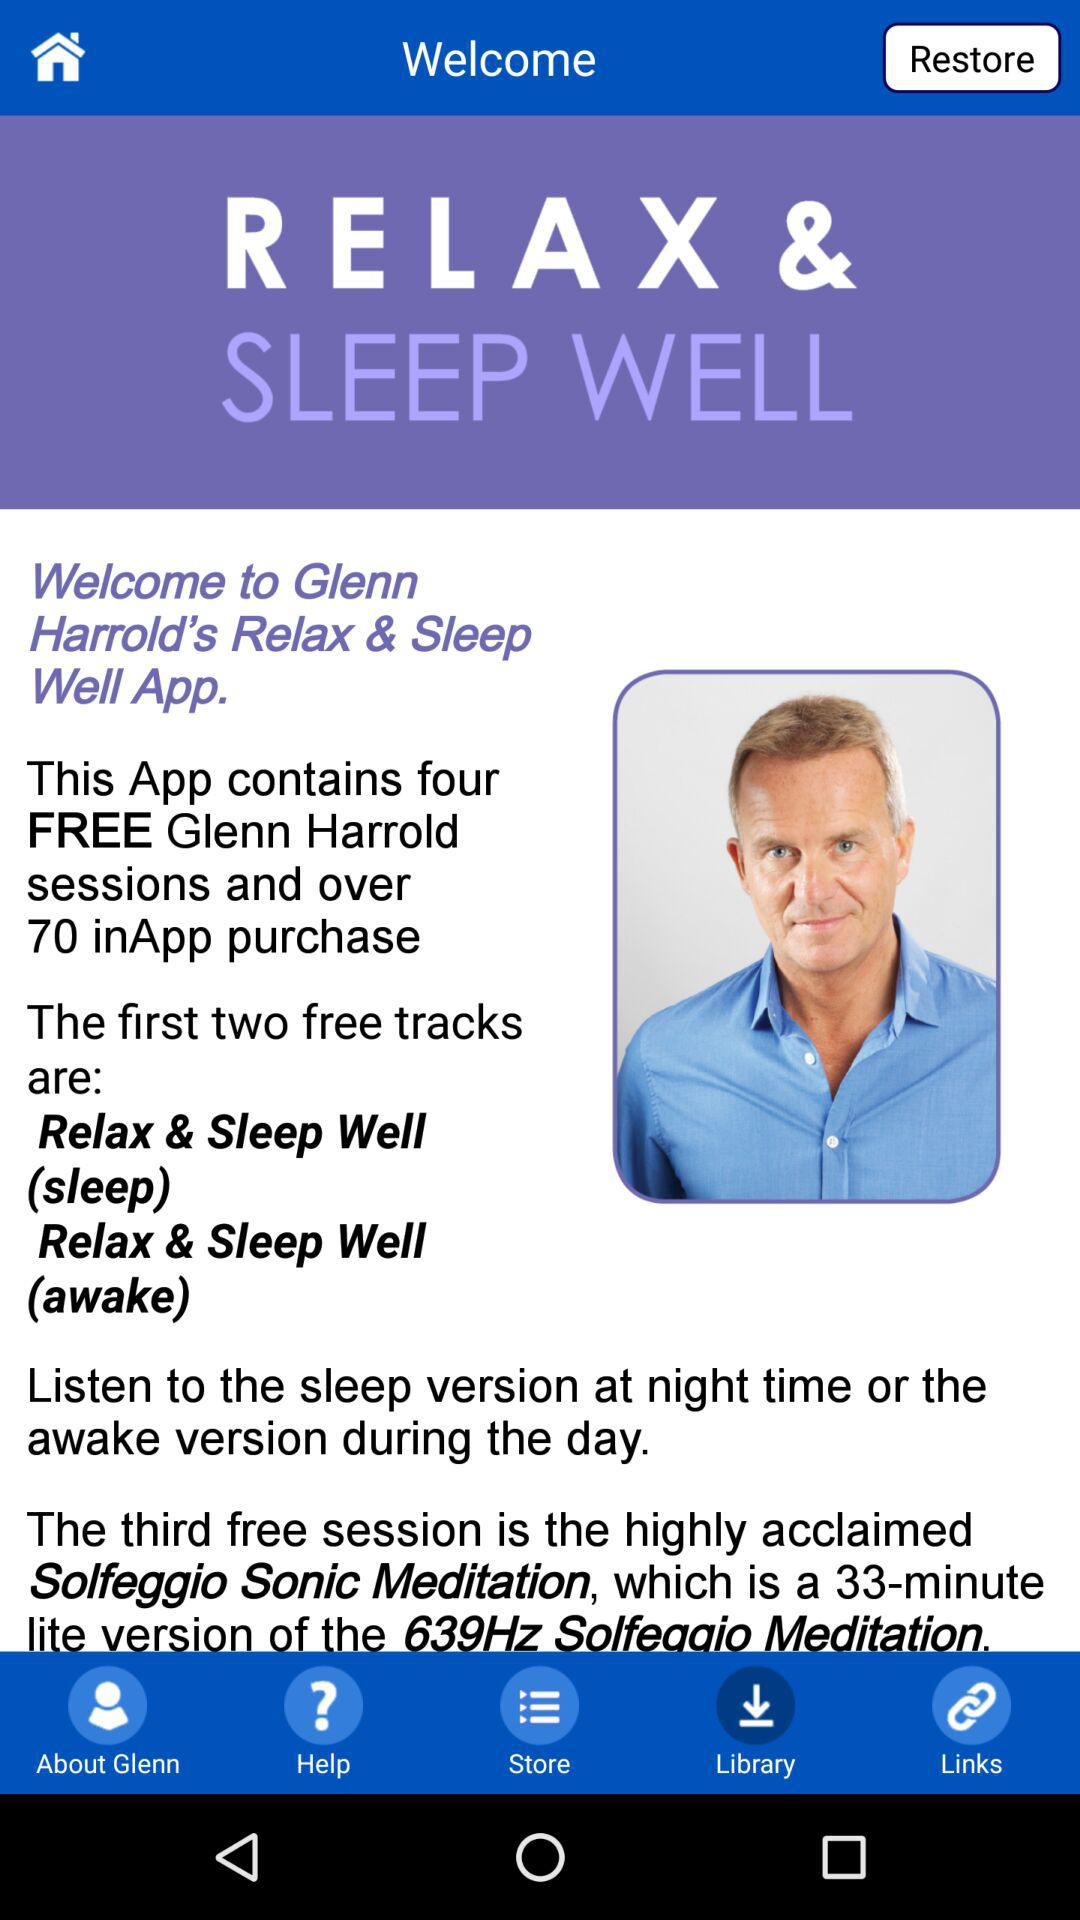How many free sessions does the app contain? The app contains four free sessions. 